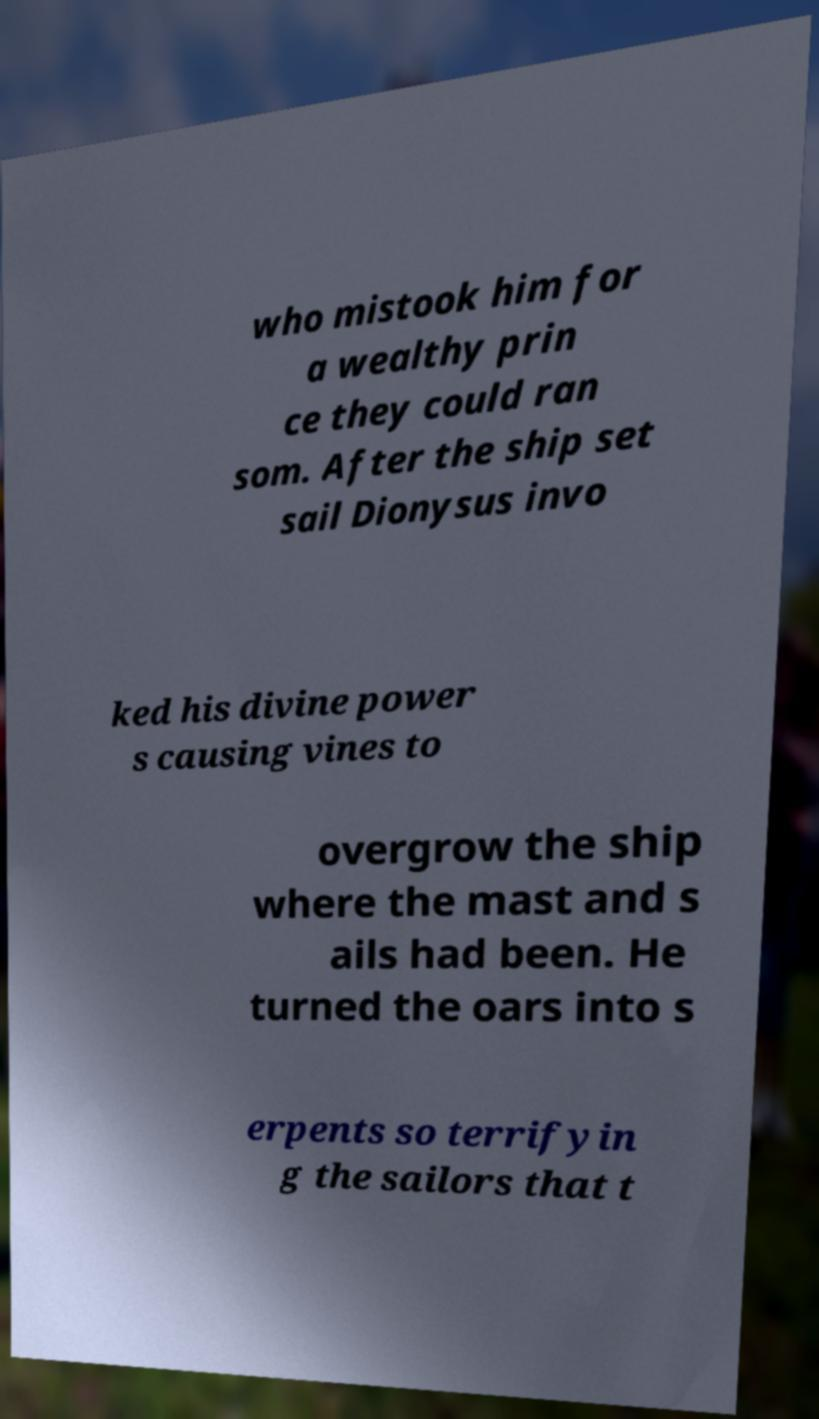Please read and relay the text visible in this image. What does it say? who mistook him for a wealthy prin ce they could ran som. After the ship set sail Dionysus invo ked his divine power s causing vines to overgrow the ship where the mast and s ails had been. He turned the oars into s erpents so terrifyin g the sailors that t 